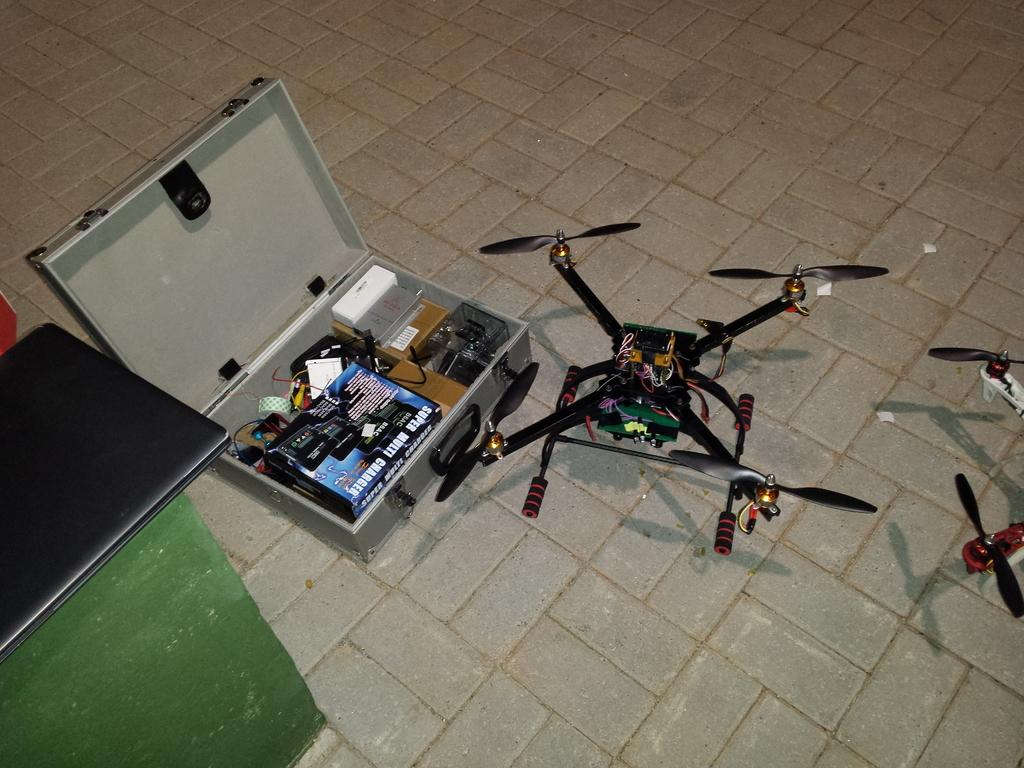What object can be seen in the image that might be used for carrying items? There is a briefcase in the image that might be used for carrying items. What is inside the briefcase? The briefcase contains items. What other object can be seen on the floor in the image? There is a drone on the floor in the image. What type of juice is being poured from the briefcase in the image? There is no juice present in the image; it features a briefcase and a drone on the floor. 